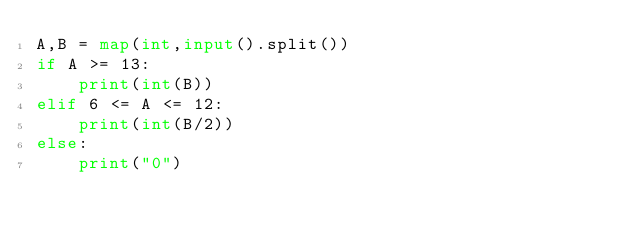Convert code to text. <code><loc_0><loc_0><loc_500><loc_500><_Python_>A,B = map(int,input().split())
if A >= 13:
    print(int(B))
elif 6 <= A <= 12:
    print(int(B/2))
else:
    print("0")</code> 